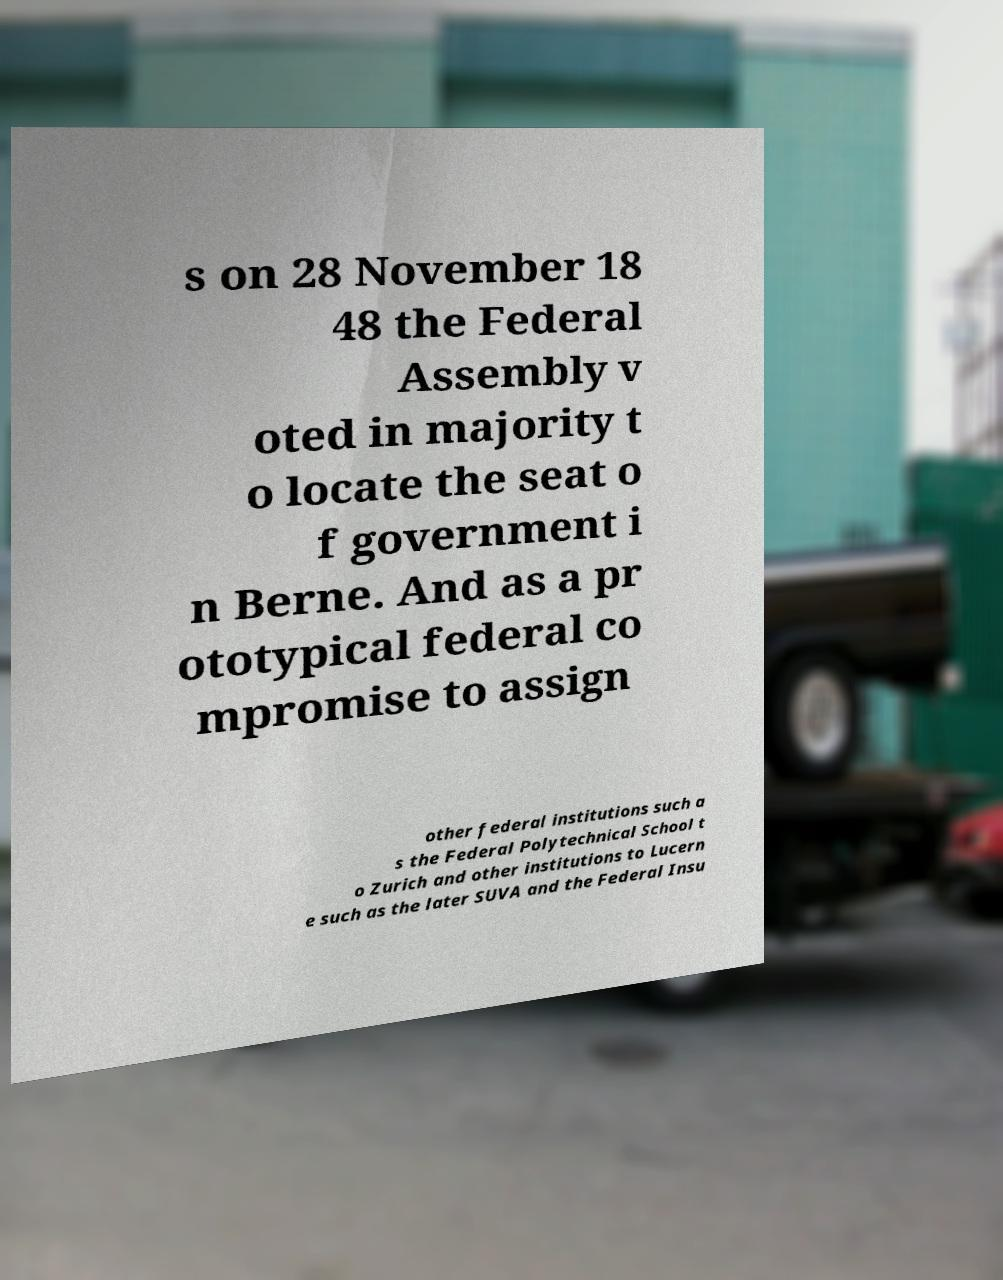I need the written content from this picture converted into text. Can you do that? s on 28 November 18 48 the Federal Assembly v oted in majority t o locate the seat o f government i n Berne. And as a pr ototypical federal co mpromise to assign other federal institutions such a s the Federal Polytechnical School t o Zurich and other institutions to Lucern e such as the later SUVA and the Federal Insu 